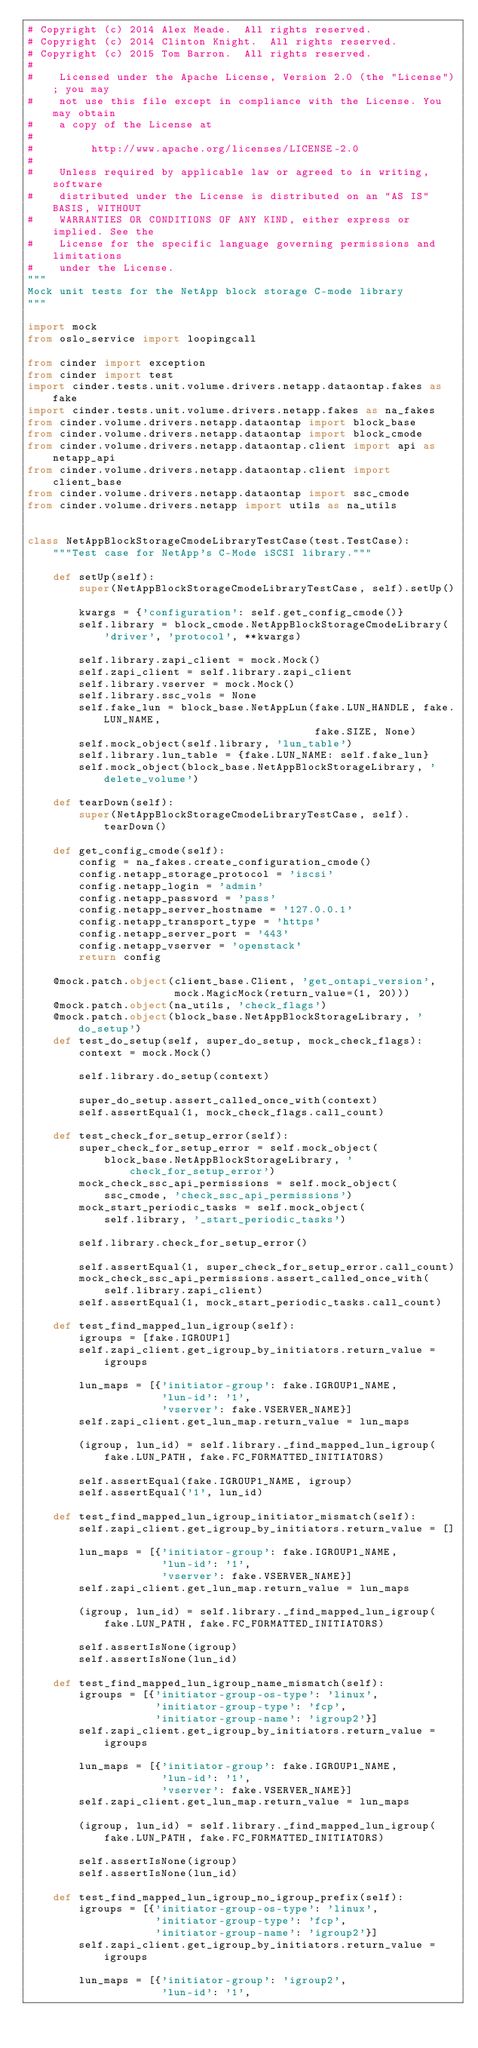<code> <loc_0><loc_0><loc_500><loc_500><_Python_># Copyright (c) 2014 Alex Meade.  All rights reserved.
# Copyright (c) 2014 Clinton Knight.  All rights reserved.
# Copyright (c) 2015 Tom Barron.  All rights reserved.
#
#    Licensed under the Apache License, Version 2.0 (the "License"); you may
#    not use this file except in compliance with the License. You may obtain
#    a copy of the License at
#
#         http://www.apache.org/licenses/LICENSE-2.0
#
#    Unless required by applicable law or agreed to in writing, software
#    distributed under the License is distributed on an "AS IS" BASIS, WITHOUT
#    WARRANTIES OR CONDITIONS OF ANY KIND, either express or implied. See the
#    License for the specific language governing permissions and limitations
#    under the License.
"""
Mock unit tests for the NetApp block storage C-mode library
"""

import mock
from oslo_service import loopingcall

from cinder import exception
from cinder import test
import cinder.tests.unit.volume.drivers.netapp.dataontap.fakes as fake
import cinder.tests.unit.volume.drivers.netapp.fakes as na_fakes
from cinder.volume.drivers.netapp.dataontap import block_base
from cinder.volume.drivers.netapp.dataontap import block_cmode
from cinder.volume.drivers.netapp.dataontap.client import api as netapp_api
from cinder.volume.drivers.netapp.dataontap.client import client_base
from cinder.volume.drivers.netapp.dataontap import ssc_cmode
from cinder.volume.drivers.netapp import utils as na_utils


class NetAppBlockStorageCmodeLibraryTestCase(test.TestCase):
    """Test case for NetApp's C-Mode iSCSI library."""

    def setUp(self):
        super(NetAppBlockStorageCmodeLibraryTestCase, self).setUp()

        kwargs = {'configuration': self.get_config_cmode()}
        self.library = block_cmode.NetAppBlockStorageCmodeLibrary(
            'driver', 'protocol', **kwargs)

        self.library.zapi_client = mock.Mock()
        self.zapi_client = self.library.zapi_client
        self.library.vserver = mock.Mock()
        self.library.ssc_vols = None
        self.fake_lun = block_base.NetAppLun(fake.LUN_HANDLE, fake.LUN_NAME,
                                             fake.SIZE, None)
        self.mock_object(self.library, 'lun_table')
        self.library.lun_table = {fake.LUN_NAME: self.fake_lun}
        self.mock_object(block_base.NetAppBlockStorageLibrary, 'delete_volume')

    def tearDown(self):
        super(NetAppBlockStorageCmodeLibraryTestCase, self).tearDown()

    def get_config_cmode(self):
        config = na_fakes.create_configuration_cmode()
        config.netapp_storage_protocol = 'iscsi'
        config.netapp_login = 'admin'
        config.netapp_password = 'pass'
        config.netapp_server_hostname = '127.0.0.1'
        config.netapp_transport_type = 'https'
        config.netapp_server_port = '443'
        config.netapp_vserver = 'openstack'
        return config

    @mock.patch.object(client_base.Client, 'get_ontapi_version',
                       mock.MagicMock(return_value=(1, 20)))
    @mock.patch.object(na_utils, 'check_flags')
    @mock.patch.object(block_base.NetAppBlockStorageLibrary, 'do_setup')
    def test_do_setup(self, super_do_setup, mock_check_flags):
        context = mock.Mock()

        self.library.do_setup(context)

        super_do_setup.assert_called_once_with(context)
        self.assertEqual(1, mock_check_flags.call_count)

    def test_check_for_setup_error(self):
        super_check_for_setup_error = self.mock_object(
            block_base.NetAppBlockStorageLibrary, 'check_for_setup_error')
        mock_check_ssc_api_permissions = self.mock_object(
            ssc_cmode, 'check_ssc_api_permissions')
        mock_start_periodic_tasks = self.mock_object(
            self.library, '_start_periodic_tasks')

        self.library.check_for_setup_error()

        self.assertEqual(1, super_check_for_setup_error.call_count)
        mock_check_ssc_api_permissions.assert_called_once_with(
            self.library.zapi_client)
        self.assertEqual(1, mock_start_periodic_tasks.call_count)

    def test_find_mapped_lun_igroup(self):
        igroups = [fake.IGROUP1]
        self.zapi_client.get_igroup_by_initiators.return_value = igroups

        lun_maps = [{'initiator-group': fake.IGROUP1_NAME,
                     'lun-id': '1',
                     'vserver': fake.VSERVER_NAME}]
        self.zapi_client.get_lun_map.return_value = lun_maps

        (igroup, lun_id) = self.library._find_mapped_lun_igroup(
            fake.LUN_PATH, fake.FC_FORMATTED_INITIATORS)

        self.assertEqual(fake.IGROUP1_NAME, igroup)
        self.assertEqual('1', lun_id)

    def test_find_mapped_lun_igroup_initiator_mismatch(self):
        self.zapi_client.get_igroup_by_initiators.return_value = []

        lun_maps = [{'initiator-group': fake.IGROUP1_NAME,
                     'lun-id': '1',
                     'vserver': fake.VSERVER_NAME}]
        self.zapi_client.get_lun_map.return_value = lun_maps

        (igroup, lun_id) = self.library._find_mapped_lun_igroup(
            fake.LUN_PATH, fake.FC_FORMATTED_INITIATORS)

        self.assertIsNone(igroup)
        self.assertIsNone(lun_id)

    def test_find_mapped_lun_igroup_name_mismatch(self):
        igroups = [{'initiator-group-os-type': 'linux',
                    'initiator-group-type': 'fcp',
                    'initiator-group-name': 'igroup2'}]
        self.zapi_client.get_igroup_by_initiators.return_value = igroups

        lun_maps = [{'initiator-group': fake.IGROUP1_NAME,
                     'lun-id': '1',
                     'vserver': fake.VSERVER_NAME}]
        self.zapi_client.get_lun_map.return_value = lun_maps

        (igroup, lun_id) = self.library._find_mapped_lun_igroup(
            fake.LUN_PATH, fake.FC_FORMATTED_INITIATORS)

        self.assertIsNone(igroup)
        self.assertIsNone(lun_id)

    def test_find_mapped_lun_igroup_no_igroup_prefix(self):
        igroups = [{'initiator-group-os-type': 'linux',
                    'initiator-group-type': 'fcp',
                    'initiator-group-name': 'igroup2'}]
        self.zapi_client.get_igroup_by_initiators.return_value = igroups

        lun_maps = [{'initiator-group': 'igroup2',
                     'lun-id': '1',</code> 